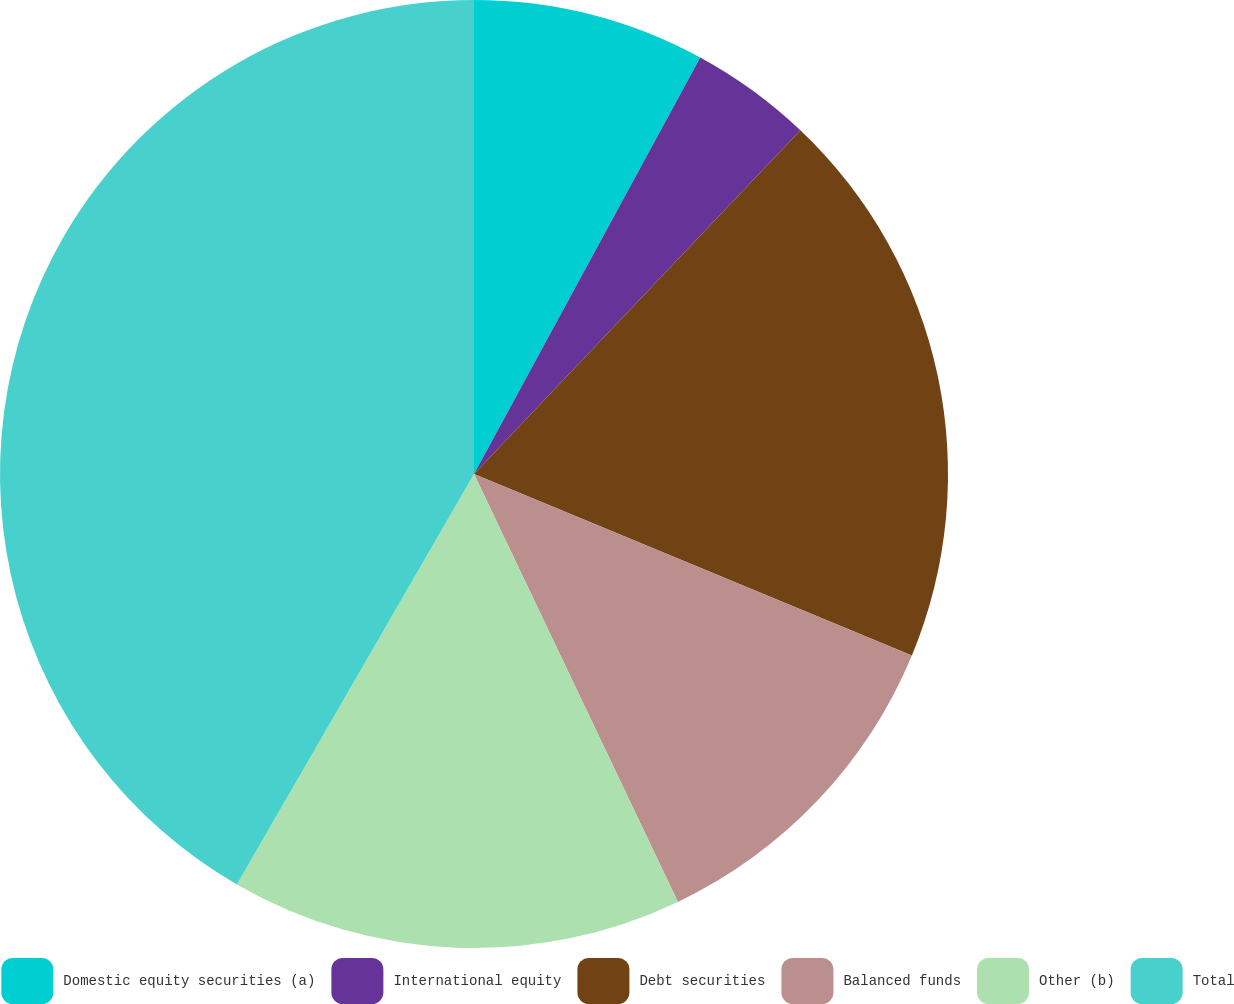<chart> <loc_0><loc_0><loc_500><loc_500><pie_chart><fcel>Domestic equity securities (a)<fcel>International equity<fcel>Debt securities<fcel>Balanced funds<fcel>Other (b)<fcel>Total<nl><fcel>7.92%<fcel>4.17%<fcel>19.17%<fcel>11.67%<fcel>15.42%<fcel>41.67%<nl></chart> 